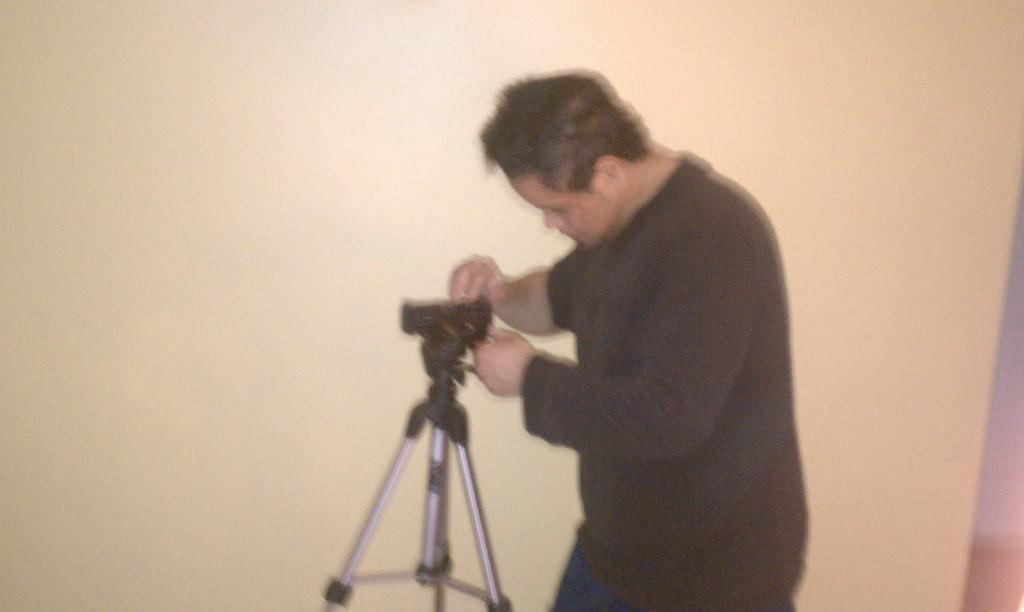Who is present in the image? There is a man in the image. What is the man holding in the image? The man is holding a camera. How is the camera positioned in the image? The camera is on a tripod. What can be seen in the background of the image? There is a wall in the background of the image. How many friends is the man touching in the image? There are no friends present in the image, and the man is not touching anyone. 